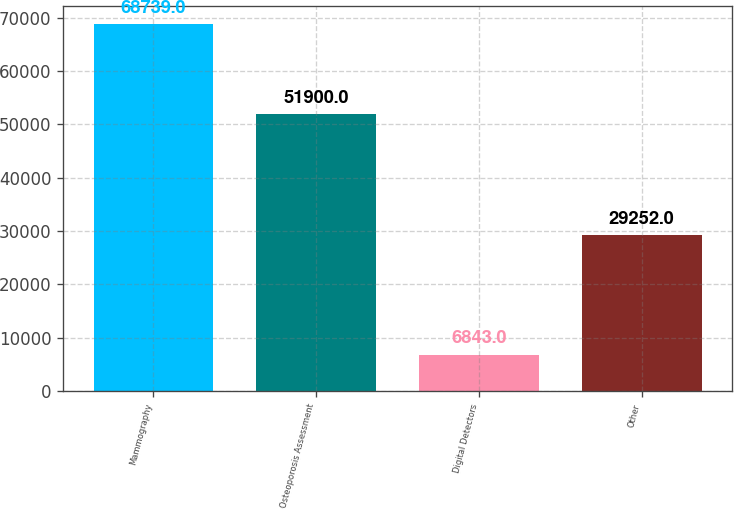Convert chart. <chart><loc_0><loc_0><loc_500><loc_500><bar_chart><fcel>Mammography<fcel>Osteoporosis Assessment<fcel>Digital Detectors<fcel>Other<nl><fcel>68739<fcel>51900<fcel>6843<fcel>29252<nl></chart> 